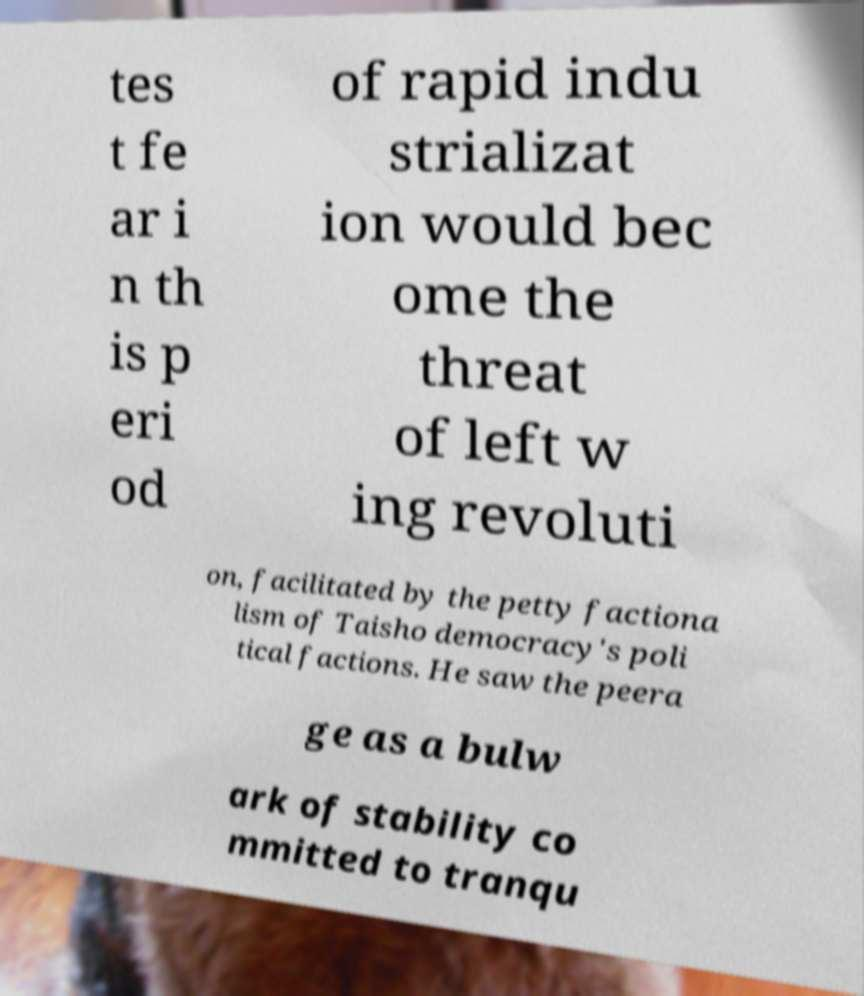Can you read and provide the text displayed in the image?This photo seems to have some interesting text. Can you extract and type it out for me? tes t fe ar i n th is p eri od of rapid indu strializat ion would bec ome the threat of left w ing revoluti on, facilitated by the petty factiona lism of Taisho democracy's poli tical factions. He saw the peera ge as a bulw ark of stability co mmitted to tranqu 